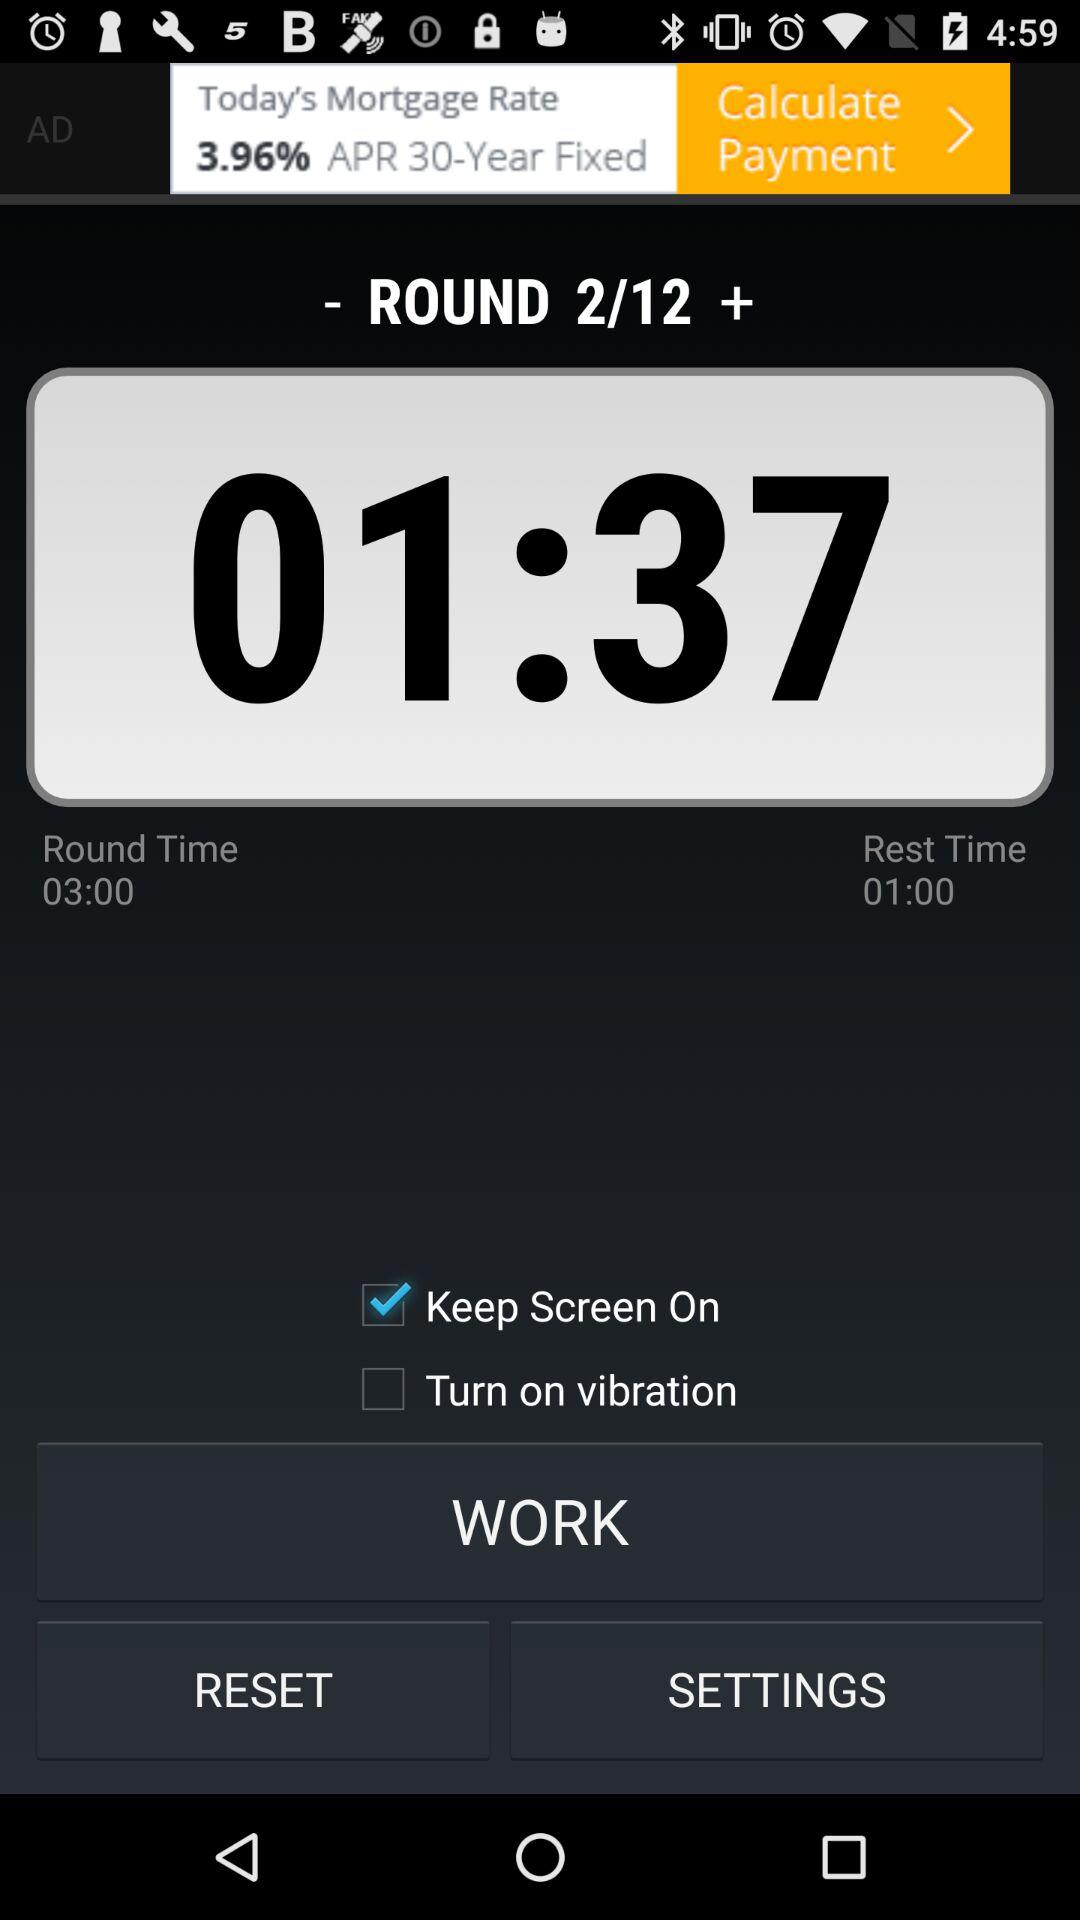What is "Rest Time"? The "Rest Time" is 01:00. 